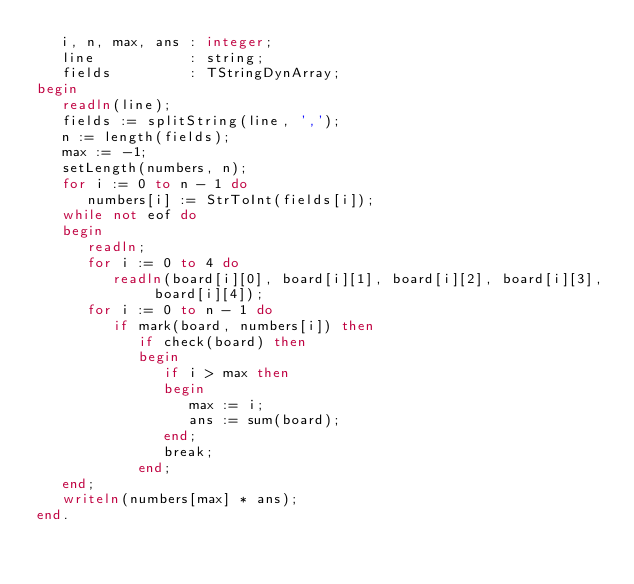Convert code to text. <code><loc_0><loc_0><loc_500><loc_500><_Pascal_>   i, n, max, ans : integer;
   line           : string;
   fields         : TStringDynArray;
begin
   readln(line);
   fields := splitString(line, ',');
   n := length(fields);
   max := -1;
   setLength(numbers, n);
   for i := 0 to n - 1 do
      numbers[i] := StrToInt(fields[i]);
   while not eof do
   begin
      readln;
      for i := 0 to 4 do
         readln(board[i][0], board[i][1], board[i][2], board[i][3], board[i][4]);
      for i := 0 to n - 1 do
         if mark(board, numbers[i]) then
            if check(board) then
            begin
               if i > max then
               begin
                  max := i;
                  ans := sum(board);
               end;
               break;
            end;
   end;
   writeln(numbers[max] * ans);
end.
</code> 